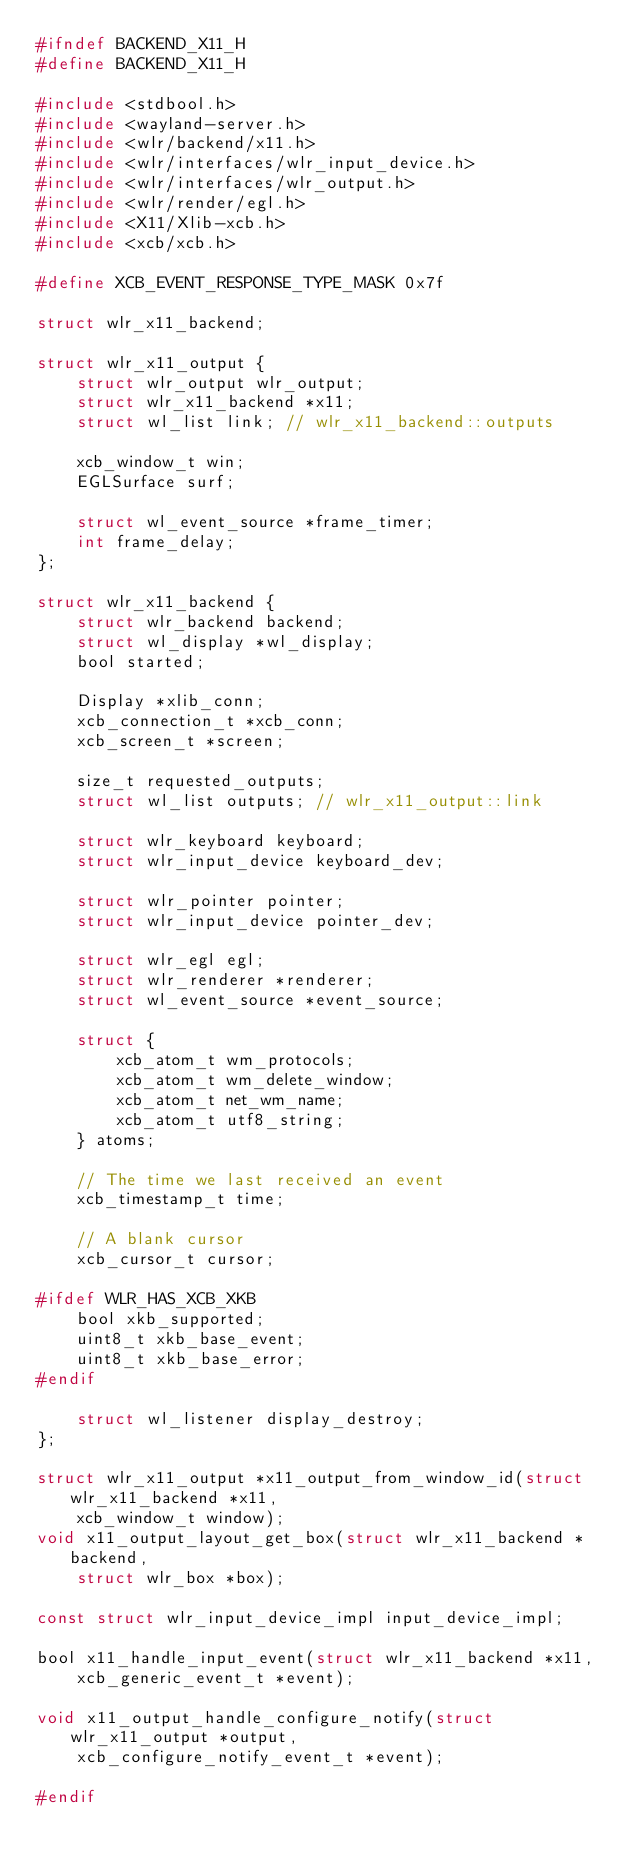Convert code to text. <code><loc_0><loc_0><loc_500><loc_500><_C_>#ifndef BACKEND_X11_H
#define BACKEND_X11_H

#include <stdbool.h>
#include <wayland-server.h>
#include <wlr/backend/x11.h>
#include <wlr/interfaces/wlr_input_device.h>
#include <wlr/interfaces/wlr_output.h>
#include <wlr/render/egl.h>
#include <X11/Xlib-xcb.h>
#include <xcb/xcb.h>

#define XCB_EVENT_RESPONSE_TYPE_MASK 0x7f

struct wlr_x11_backend;

struct wlr_x11_output {
	struct wlr_output wlr_output;
	struct wlr_x11_backend *x11;
	struct wl_list link; // wlr_x11_backend::outputs

	xcb_window_t win;
	EGLSurface surf;

	struct wl_event_source *frame_timer;
	int frame_delay;
};

struct wlr_x11_backend {
	struct wlr_backend backend;
	struct wl_display *wl_display;
	bool started;

	Display *xlib_conn;
	xcb_connection_t *xcb_conn;
	xcb_screen_t *screen;

	size_t requested_outputs;
	struct wl_list outputs; // wlr_x11_output::link

	struct wlr_keyboard keyboard;
	struct wlr_input_device keyboard_dev;

	struct wlr_pointer pointer;
	struct wlr_input_device pointer_dev;

	struct wlr_egl egl;
	struct wlr_renderer *renderer;
	struct wl_event_source *event_source;

	struct {
		xcb_atom_t wm_protocols;
		xcb_atom_t wm_delete_window;
		xcb_atom_t net_wm_name;
		xcb_atom_t utf8_string;
	} atoms;

	// The time we last received an event
	xcb_timestamp_t time;

	// A blank cursor
	xcb_cursor_t cursor;

#ifdef WLR_HAS_XCB_XKB
	bool xkb_supported;
	uint8_t xkb_base_event;
	uint8_t xkb_base_error;
#endif

	struct wl_listener display_destroy;
};

struct wlr_x11_output *x11_output_from_window_id(struct wlr_x11_backend *x11,
	xcb_window_t window);
void x11_output_layout_get_box(struct wlr_x11_backend *backend,
	struct wlr_box *box);

const struct wlr_input_device_impl input_device_impl;

bool x11_handle_input_event(struct wlr_x11_backend *x11,
	xcb_generic_event_t *event);

void x11_output_handle_configure_notify(struct wlr_x11_output *output,
	xcb_configure_notify_event_t *event);

#endif
</code> 